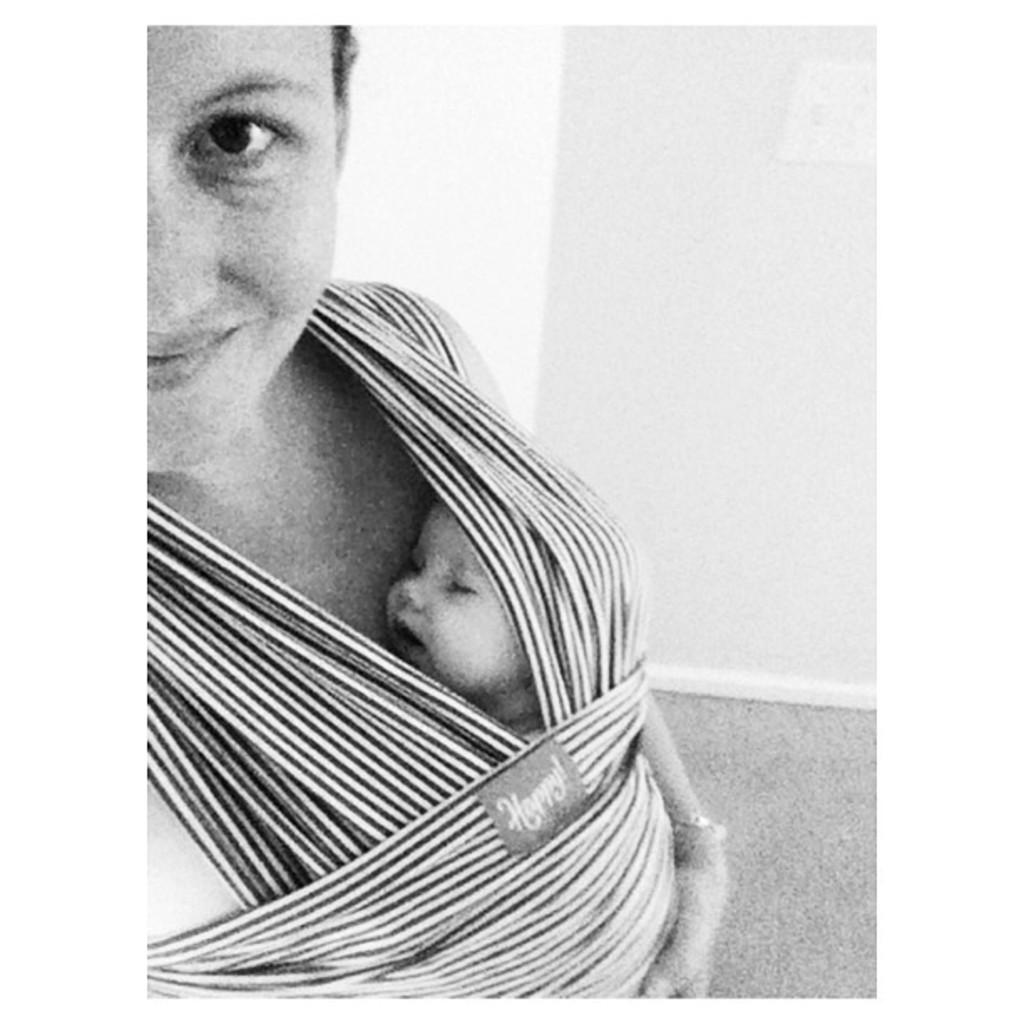What is the main subject of the image? The main subject of the image is a woman. What is the woman doing in the image? The woman is standing and carrying a child. What can be seen in the background of the image? There is a white color wall in the backdrop to the right. How would you describe the quality of the image? The image is blurred. What type of rose can be seen in the woman's hand in the image? There is no rose present in the image; the woman is carrying a child. What is the woman's opinion on the topic of climate change in the image? The image does not provide any information about the woman's opinion on climate change or any other topic. 